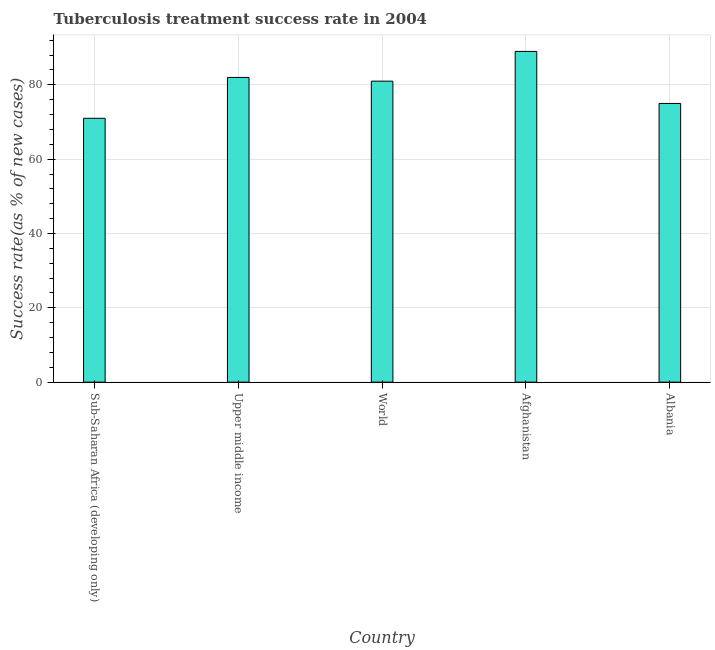What is the title of the graph?
Ensure brevity in your answer.  Tuberculosis treatment success rate in 2004. What is the label or title of the X-axis?
Keep it short and to the point. Country. What is the label or title of the Y-axis?
Keep it short and to the point. Success rate(as % of new cases). What is the tuberculosis treatment success rate in Afghanistan?
Your answer should be very brief. 89. Across all countries, what is the maximum tuberculosis treatment success rate?
Make the answer very short. 89. Across all countries, what is the minimum tuberculosis treatment success rate?
Provide a succinct answer. 71. In which country was the tuberculosis treatment success rate maximum?
Your answer should be very brief. Afghanistan. In which country was the tuberculosis treatment success rate minimum?
Give a very brief answer. Sub-Saharan Africa (developing only). What is the sum of the tuberculosis treatment success rate?
Provide a succinct answer. 398. What is the difference between the tuberculosis treatment success rate in Upper middle income and World?
Keep it short and to the point. 1. What is the average tuberculosis treatment success rate per country?
Offer a terse response. 79. What is the median tuberculosis treatment success rate?
Provide a short and direct response. 81. In how many countries, is the tuberculosis treatment success rate greater than 20 %?
Your answer should be very brief. 5. What is the ratio of the tuberculosis treatment success rate in Afghanistan to that in Albania?
Your answer should be compact. 1.19. Is the tuberculosis treatment success rate in Albania less than that in Upper middle income?
Your answer should be compact. Yes. What is the difference between the highest and the second highest tuberculosis treatment success rate?
Your response must be concise. 7. Is the sum of the tuberculosis treatment success rate in Upper middle income and World greater than the maximum tuberculosis treatment success rate across all countries?
Provide a succinct answer. Yes. What is the difference between the highest and the lowest tuberculosis treatment success rate?
Offer a terse response. 18. In how many countries, is the tuberculosis treatment success rate greater than the average tuberculosis treatment success rate taken over all countries?
Make the answer very short. 3. How many bars are there?
Provide a succinct answer. 5. What is the difference between two consecutive major ticks on the Y-axis?
Provide a succinct answer. 20. What is the Success rate(as % of new cases) in Afghanistan?
Make the answer very short. 89. What is the difference between the Success rate(as % of new cases) in Sub-Saharan Africa (developing only) and Upper middle income?
Make the answer very short. -11. What is the difference between the Success rate(as % of new cases) in Sub-Saharan Africa (developing only) and World?
Your answer should be compact. -10. What is the difference between the Success rate(as % of new cases) in Sub-Saharan Africa (developing only) and Afghanistan?
Offer a terse response. -18. What is the difference between the Success rate(as % of new cases) in Upper middle income and Albania?
Give a very brief answer. 7. What is the ratio of the Success rate(as % of new cases) in Sub-Saharan Africa (developing only) to that in Upper middle income?
Your response must be concise. 0.87. What is the ratio of the Success rate(as % of new cases) in Sub-Saharan Africa (developing only) to that in World?
Make the answer very short. 0.88. What is the ratio of the Success rate(as % of new cases) in Sub-Saharan Africa (developing only) to that in Afghanistan?
Offer a very short reply. 0.8. What is the ratio of the Success rate(as % of new cases) in Sub-Saharan Africa (developing only) to that in Albania?
Provide a short and direct response. 0.95. What is the ratio of the Success rate(as % of new cases) in Upper middle income to that in Afghanistan?
Offer a terse response. 0.92. What is the ratio of the Success rate(as % of new cases) in Upper middle income to that in Albania?
Your answer should be very brief. 1.09. What is the ratio of the Success rate(as % of new cases) in World to that in Afghanistan?
Keep it short and to the point. 0.91. What is the ratio of the Success rate(as % of new cases) in Afghanistan to that in Albania?
Your answer should be very brief. 1.19. 